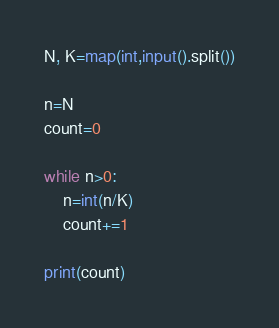Convert code to text. <code><loc_0><loc_0><loc_500><loc_500><_Python_>N, K=map(int,input().split())

n=N
count=0

while n>0:
    n=int(n/K)
    count+=1

print(count)</code> 